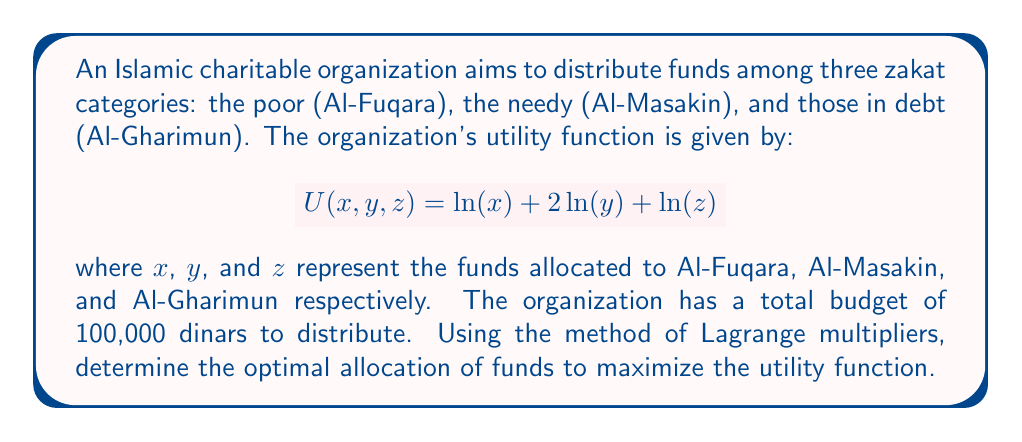Provide a solution to this math problem. To solve this problem, we'll use the method of Lagrange multipliers:

1) First, we set up the constraint equation:
   $$g(x, y, z) = x + y + z - 100000 = 0$$

2) Now, we form the Lagrangian function:
   $$L(x, y, z, \lambda) = \ln(x) + 2\ln(y) + \ln(z) - \lambda(x + y + z - 100000)$$

3) We take partial derivatives and set them equal to zero:

   $$\frac{\partial L}{\partial x} = \frac{1}{x} - \lambda = 0$$
   $$\frac{\partial L}{\partial y} = \frac{2}{y} - \lambda = 0$$
   $$\frac{\partial L}{\partial z} = \frac{1}{z} - \lambda = 0$$
   $$\frac{\partial L}{\partial \lambda} = x + y + z - 100000 = 0$$

4) From these equations, we can deduce:
   $$x = \frac{1}{\lambda}, y = \frac{2}{\lambda}, z = \frac{1}{\lambda}$$

5) Substituting these into the constraint equation:
   $$\frac{1}{\lambda} + \frac{2}{\lambda} + \frac{1}{\lambda} = 100000$$
   $$\frac{4}{\lambda} = 100000$$
   $$\lambda = \frac{1}{25000}$$

6) Now we can solve for x, y, and z:
   $$x = 25000, y = 50000, z = 25000$$

Therefore, the optimal allocation is 25,000 dinars for Al-Fuqara, 50,000 dinars for Al-Masakin, and 25,000 dinars for Al-Gharimun.
Answer: Al-Fuqara: 25,000 dinars; Al-Masakin: 50,000 dinars; Al-Gharimun: 25,000 dinars 